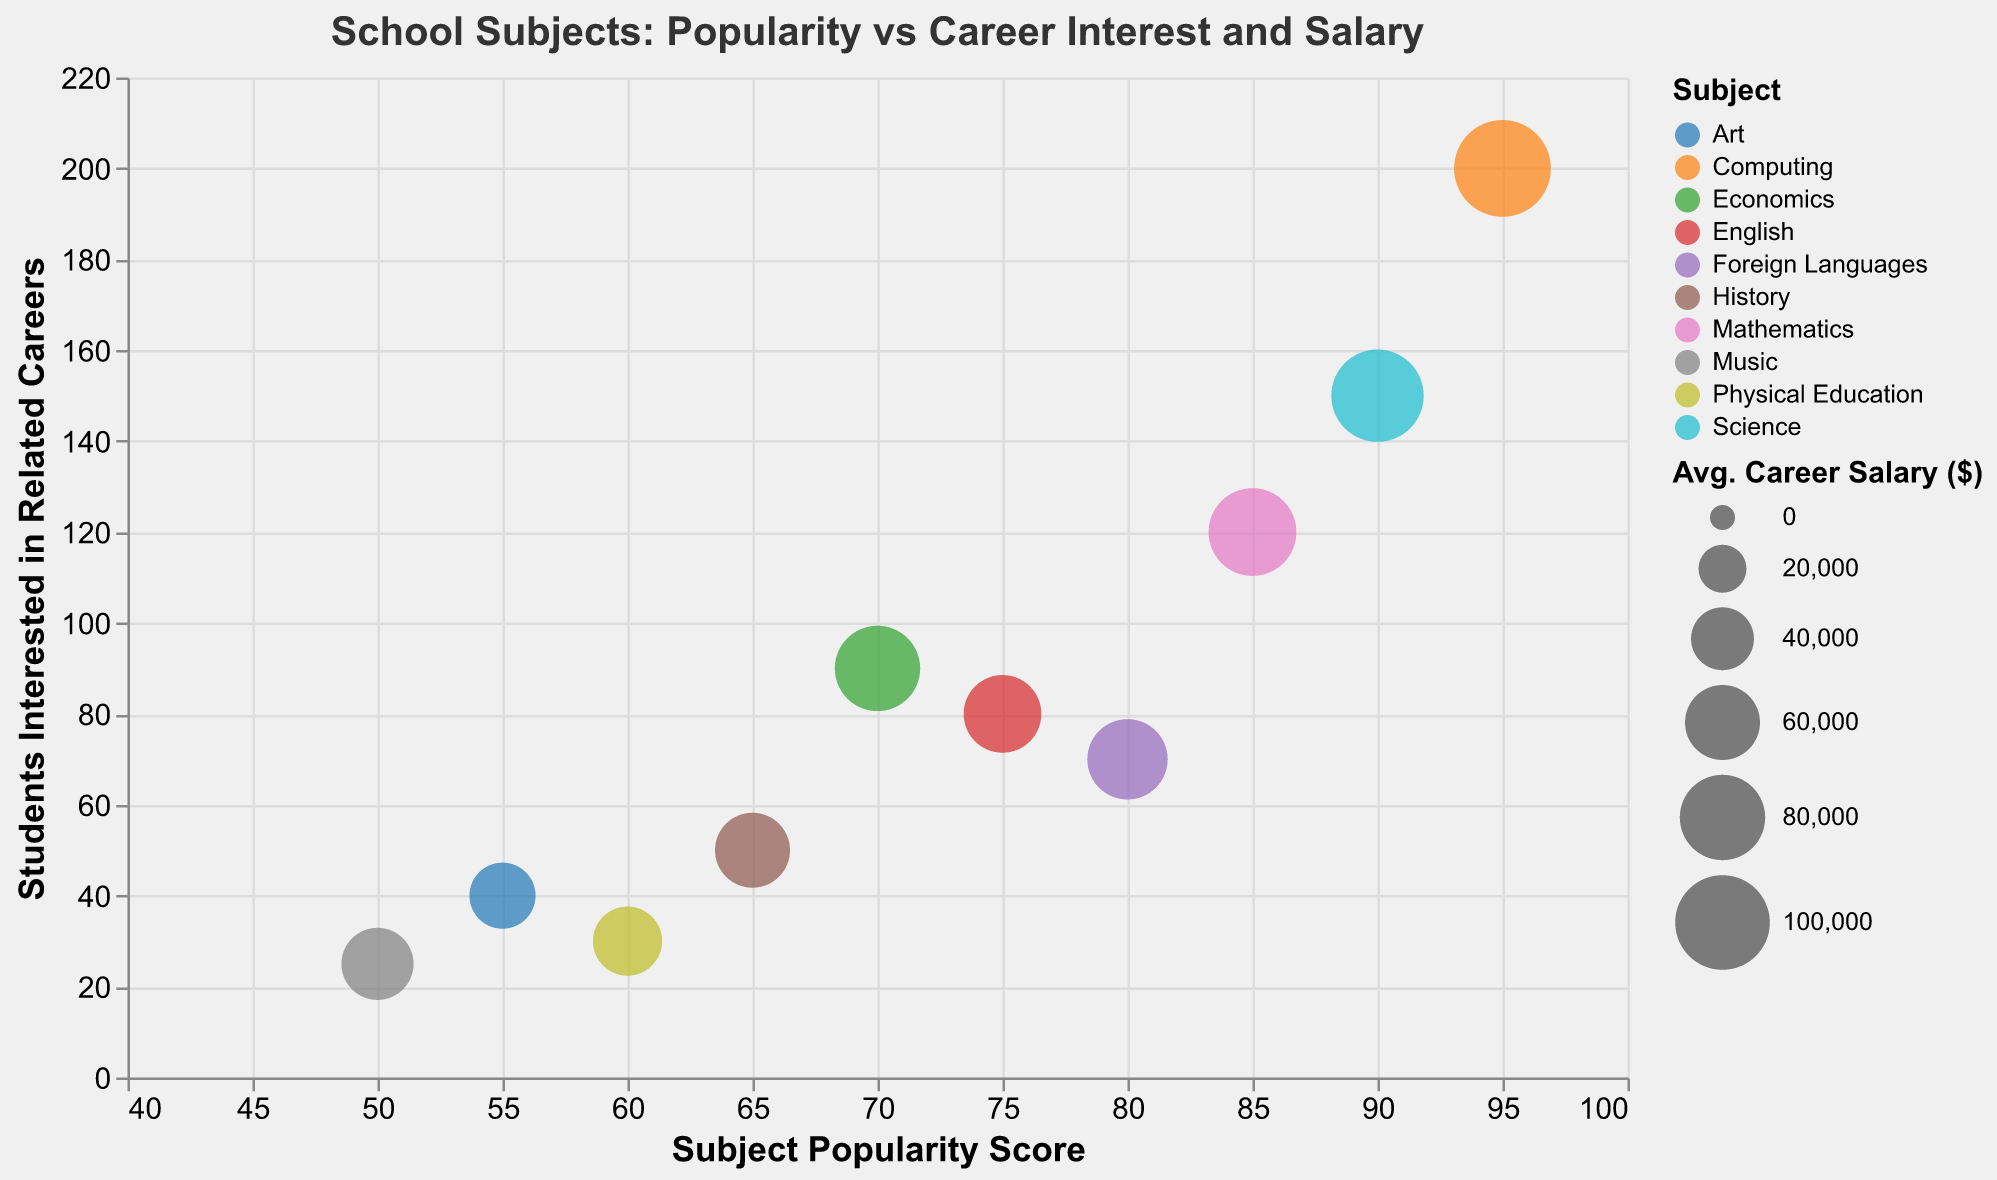what is the title of the figure? The title is usually placed at the top of the chart and is clearly labeled for understanding the purpose of the data visualization.
Answer: School Subjects: Popularity vs Career Interest and Salary how many subjects are represented in the chart? Count the number of distinct bubbles, with each bubble representing one subject. There are 10 subjects in total.
Answer: 10 which subject has the highest popularity score? Look for the bubble positioned furthermost to the right on the x-axis, which represents the "Popularity Score."
Answer: Computing which subject has the lowest average career salary? Find the smallest bubble since the bubble size represents the "Average Career Salary ($)."
Answer: Art what is the popularity score of English? Identify the bubble corresponding to English, and read its x-axis value.
Answer: 75 how many students are interested in music-related careers? Locate the bubble representing Music, and read its y-axis value to find the number of students interested.
Answer: 25 which subject has a lower popularity score than History but a higher number of students interested in related careers than Music? History has a popularity score of 65. Music has 25 students interested in related careers. Look for a subject with a popularity score < 65 and students interested > 25. Art fits both criteria.
Answer: Art compare the average career salaries of Mathematics and Economics. Which has a higher salary? Find the bubbles for Mathematics and Economics, and compare their sizes. Mathematics has a larger bubble indicating a higher salary.
Answer: Mathematics what is the difference in students interested in related careers between Science and Foreign Languages? Science has 150 students and Foreign Languages has 70. Subtract to find the difference: 150 - 70 = 80.
Answer: 80 which subject has a higher popularity score and a higher average career salary compared to English? English has a popularity score of 75 and an average career salary of $65,000. Find a subject with higher values in both criteria. Computing fits both criteria.
Answer: Computing 